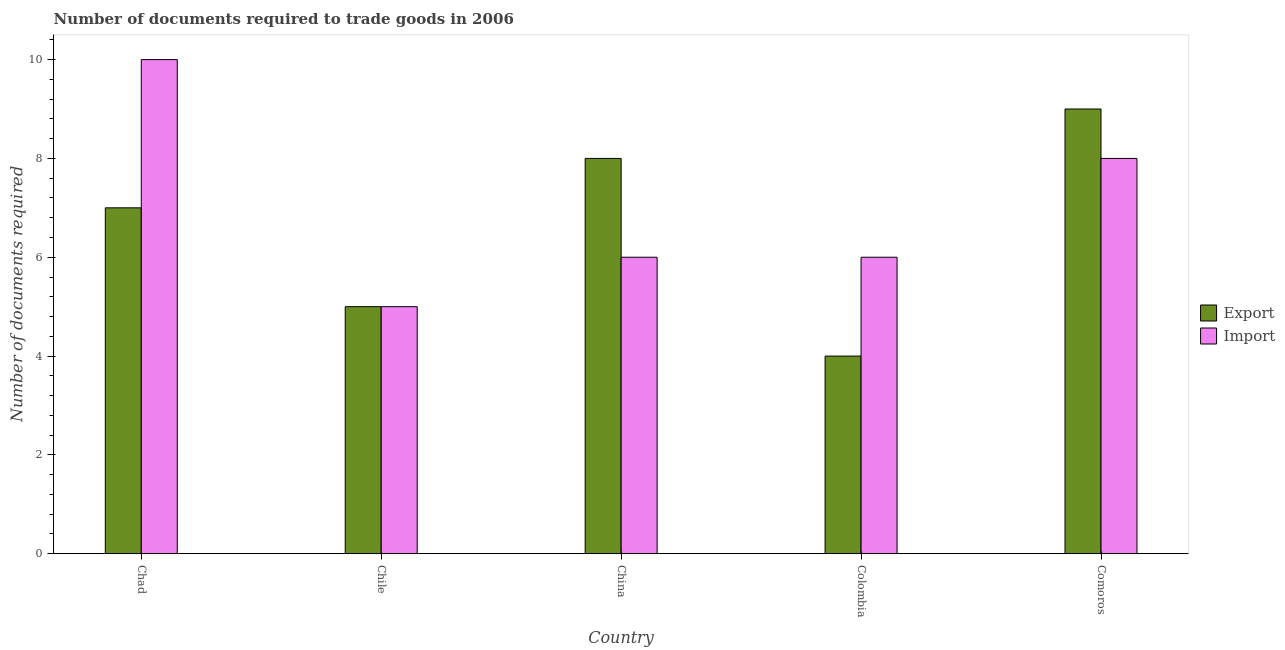How many different coloured bars are there?
Offer a very short reply. 2. Are the number of bars on each tick of the X-axis equal?
Make the answer very short. Yes. How many bars are there on the 2nd tick from the left?
Your answer should be compact. 2. How many bars are there on the 2nd tick from the right?
Offer a very short reply. 2. What is the label of the 5th group of bars from the left?
Offer a very short reply. Comoros. Across all countries, what is the minimum number of documents required to export goods?
Ensure brevity in your answer.  4. In which country was the number of documents required to import goods maximum?
Make the answer very short. Chad. In which country was the number of documents required to export goods minimum?
Make the answer very short. Colombia. What is the total number of documents required to import goods in the graph?
Ensure brevity in your answer.  35. What is the difference between the number of documents required to import goods in Chad and that in China?
Ensure brevity in your answer.  4. What is the difference between the number of documents required to import goods in China and the number of documents required to export goods in Chile?
Offer a very short reply. 1. What is the average number of documents required to import goods per country?
Ensure brevity in your answer.  7. What is the difference between the number of documents required to export goods and number of documents required to import goods in Comoros?
Your response must be concise. 1. In how many countries, is the number of documents required to import goods greater than 1.2000000000000002 ?
Ensure brevity in your answer.  5. What is the ratio of the number of documents required to import goods in Chad to that in Colombia?
Provide a short and direct response. 1.67. Is the difference between the number of documents required to import goods in Chile and Comoros greater than the difference between the number of documents required to export goods in Chile and Comoros?
Give a very brief answer. Yes. What is the difference between the highest and the second highest number of documents required to export goods?
Offer a terse response. 1. In how many countries, is the number of documents required to import goods greater than the average number of documents required to import goods taken over all countries?
Your answer should be very brief. 2. Is the sum of the number of documents required to import goods in Colombia and Comoros greater than the maximum number of documents required to export goods across all countries?
Offer a very short reply. Yes. What does the 1st bar from the left in China represents?
Ensure brevity in your answer.  Export. What does the 2nd bar from the right in Comoros represents?
Make the answer very short. Export. Does the graph contain grids?
Your answer should be compact. No. Where does the legend appear in the graph?
Offer a very short reply. Center right. How many legend labels are there?
Make the answer very short. 2. How are the legend labels stacked?
Your response must be concise. Vertical. What is the title of the graph?
Ensure brevity in your answer.  Number of documents required to trade goods in 2006. Does "Food" appear as one of the legend labels in the graph?
Make the answer very short. No. What is the label or title of the X-axis?
Offer a very short reply. Country. What is the label or title of the Y-axis?
Your response must be concise. Number of documents required. What is the Number of documents required in Export in Chile?
Your answer should be very brief. 5. What is the Number of documents required in Import in Chile?
Keep it short and to the point. 5. What is the Number of documents required of Import in Comoros?
Give a very brief answer. 8. Across all countries, what is the maximum Number of documents required of Export?
Ensure brevity in your answer.  9. Across all countries, what is the maximum Number of documents required of Import?
Give a very brief answer. 10. What is the total Number of documents required of Export in the graph?
Offer a terse response. 33. What is the total Number of documents required in Import in the graph?
Your response must be concise. 35. What is the difference between the Number of documents required of Export in Chad and that in Chile?
Offer a terse response. 2. What is the difference between the Number of documents required of Import in Chad and that in China?
Your answer should be very brief. 4. What is the difference between the Number of documents required of Export in Chad and that in Colombia?
Offer a very short reply. 3. What is the difference between the Number of documents required in Import in Chad and that in Colombia?
Provide a succinct answer. 4. What is the difference between the Number of documents required of Export in Chile and that in China?
Make the answer very short. -3. What is the difference between the Number of documents required of Import in Chile and that in China?
Ensure brevity in your answer.  -1. What is the difference between the Number of documents required in Import in Chile and that in Colombia?
Make the answer very short. -1. What is the difference between the Number of documents required of Export in China and that in Colombia?
Make the answer very short. 4. What is the difference between the Number of documents required of Import in China and that in Colombia?
Offer a very short reply. 0. What is the difference between the Number of documents required in Export in Colombia and that in Comoros?
Offer a terse response. -5. What is the difference between the Number of documents required in Export in Chad and the Number of documents required in Import in Chile?
Your answer should be very brief. 2. What is the difference between the Number of documents required of Export in Chad and the Number of documents required of Import in Comoros?
Your answer should be very brief. -1. What is the difference between the Number of documents required in Export and Number of documents required in Import in Chad?
Your response must be concise. -3. What is the difference between the Number of documents required in Export and Number of documents required in Import in Chile?
Your answer should be compact. 0. What is the difference between the Number of documents required of Export and Number of documents required of Import in Colombia?
Your response must be concise. -2. What is the difference between the Number of documents required in Export and Number of documents required in Import in Comoros?
Keep it short and to the point. 1. What is the ratio of the Number of documents required in Export in Chad to that in Chile?
Provide a succinct answer. 1.4. What is the ratio of the Number of documents required of Export in Chad to that in China?
Give a very brief answer. 0.88. What is the ratio of the Number of documents required in Import in Chad to that in China?
Provide a succinct answer. 1.67. What is the ratio of the Number of documents required in Import in Chad to that in Colombia?
Provide a short and direct response. 1.67. What is the ratio of the Number of documents required in Export in Chile to that in China?
Your answer should be compact. 0.62. What is the ratio of the Number of documents required of Export in Chile to that in Colombia?
Your response must be concise. 1.25. What is the ratio of the Number of documents required of Import in Chile to that in Colombia?
Offer a very short reply. 0.83. What is the ratio of the Number of documents required in Export in Chile to that in Comoros?
Provide a succinct answer. 0.56. What is the ratio of the Number of documents required of Import in Chile to that in Comoros?
Offer a very short reply. 0.62. What is the ratio of the Number of documents required in Export in Colombia to that in Comoros?
Your answer should be compact. 0.44. What is the difference between the highest and the lowest Number of documents required in Import?
Your response must be concise. 5. 